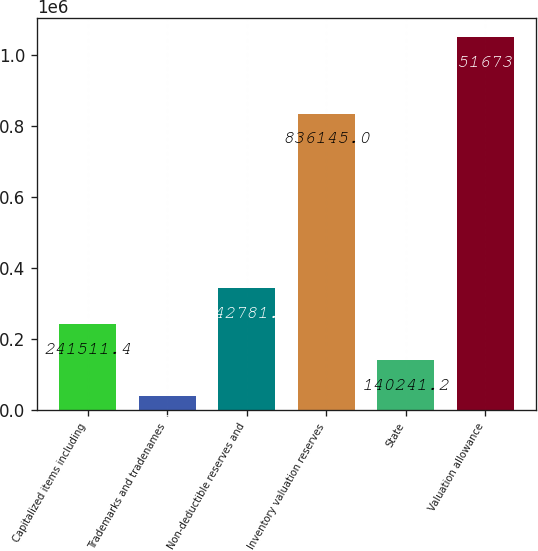Convert chart. <chart><loc_0><loc_0><loc_500><loc_500><bar_chart><fcel>Capitalized items including<fcel>Trademarks and tradenames<fcel>Non-deductible reserves and<fcel>Inventory valuation reserves<fcel>State<fcel>Valuation allowance<nl><fcel>241511<fcel>38971<fcel>342782<fcel>836145<fcel>140241<fcel>1.05167e+06<nl></chart> 